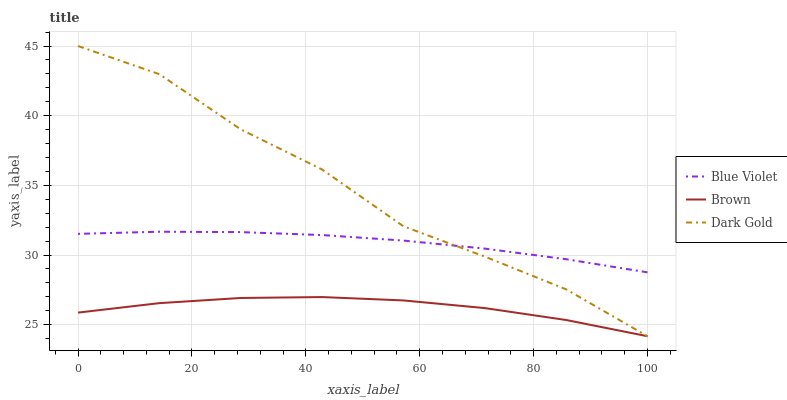Does Brown have the minimum area under the curve?
Answer yes or no. Yes. Does Dark Gold have the maximum area under the curve?
Answer yes or no. Yes. Does Blue Violet have the minimum area under the curve?
Answer yes or no. No. Does Blue Violet have the maximum area under the curve?
Answer yes or no. No. Is Blue Violet the smoothest?
Answer yes or no. Yes. Is Dark Gold the roughest?
Answer yes or no. Yes. Is Dark Gold the smoothest?
Answer yes or no. No. Is Blue Violet the roughest?
Answer yes or no. No. Does Dark Gold have the lowest value?
Answer yes or no. Yes. Does Blue Violet have the lowest value?
Answer yes or no. No. Does Dark Gold have the highest value?
Answer yes or no. Yes. Does Blue Violet have the highest value?
Answer yes or no. No. Is Brown less than Blue Violet?
Answer yes or no. Yes. Is Blue Violet greater than Brown?
Answer yes or no. Yes. Does Blue Violet intersect Dark Gold?
Answer yes or no. Yes. Is Blue Violet less than Dark Gold?
Answer yes or no. No. Is Blue Violet greater than Dark Gold?
Answer yes or no. No. Does Brown intersect Blue Violet?
Answer yes or no. No. 